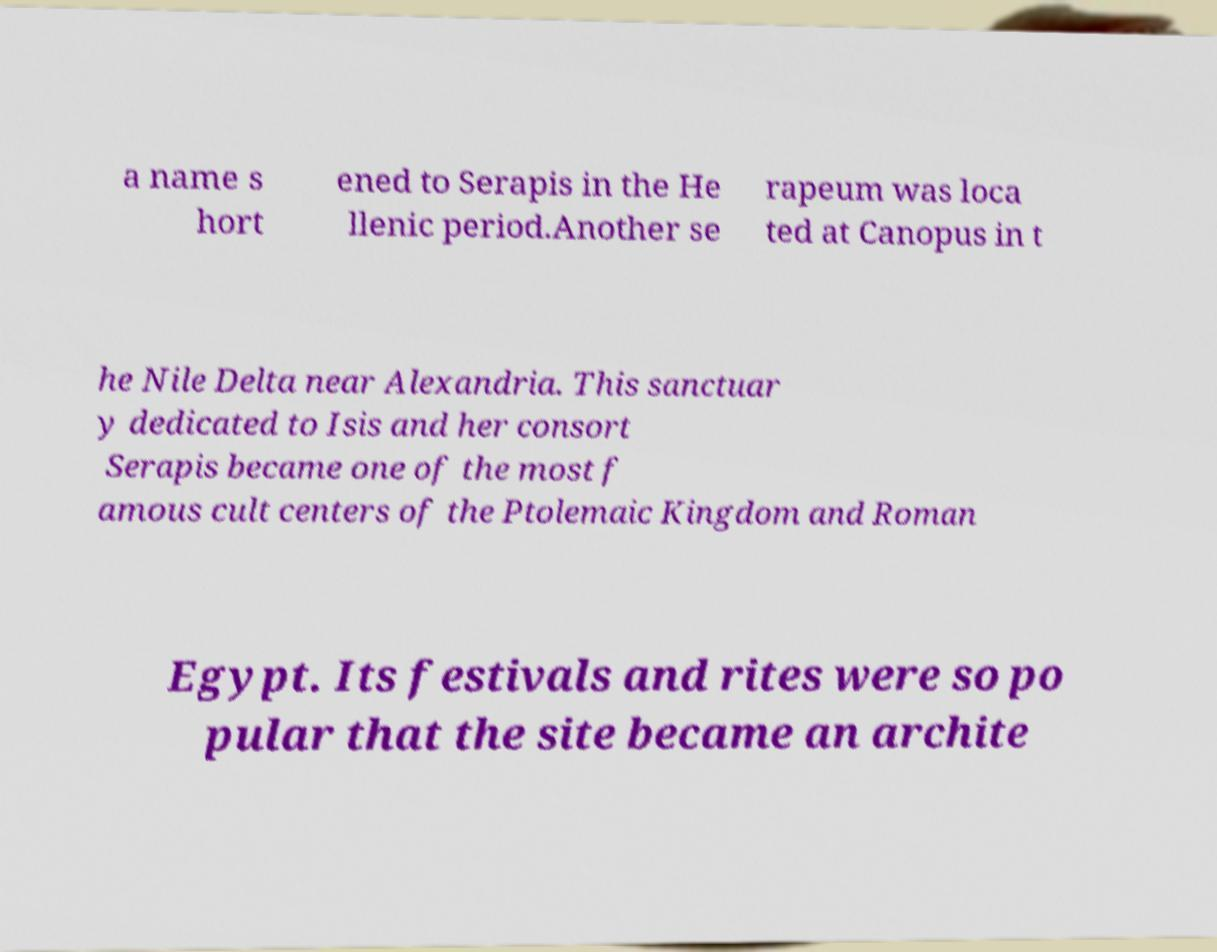Can you accurately transcribe the text from the provided image for me? a name s hort ened to Serapis in the He llenic period.Another se rapeum was loca ted at Canopus in t he Nile Delta near Alexandria. This sanctuar y dedicated to Isis and her consort Serapis became one of the most f amous cult centers of the Ptolemaic Kingdom and Roman Egypt. Its festivals and rites were so po pular that the site became an archite 